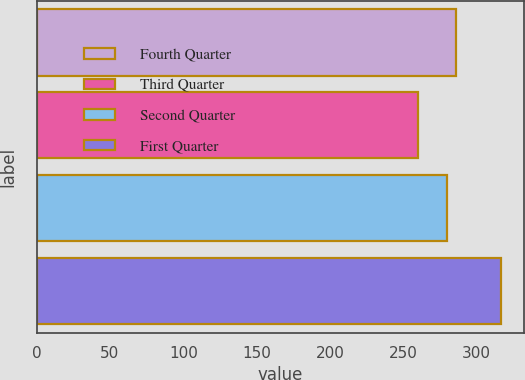Convert chart. <chart><loc_0><loc_0><loc_500><loc_500><bar_chart><fcel>Fourth Quarter<fcel>Third Quarter<fcel>Second Quarter<fcel>First Quarter<nl><fcel>285.65<fcel>260<fcel>280<fcel>316.5<nl></chart> 